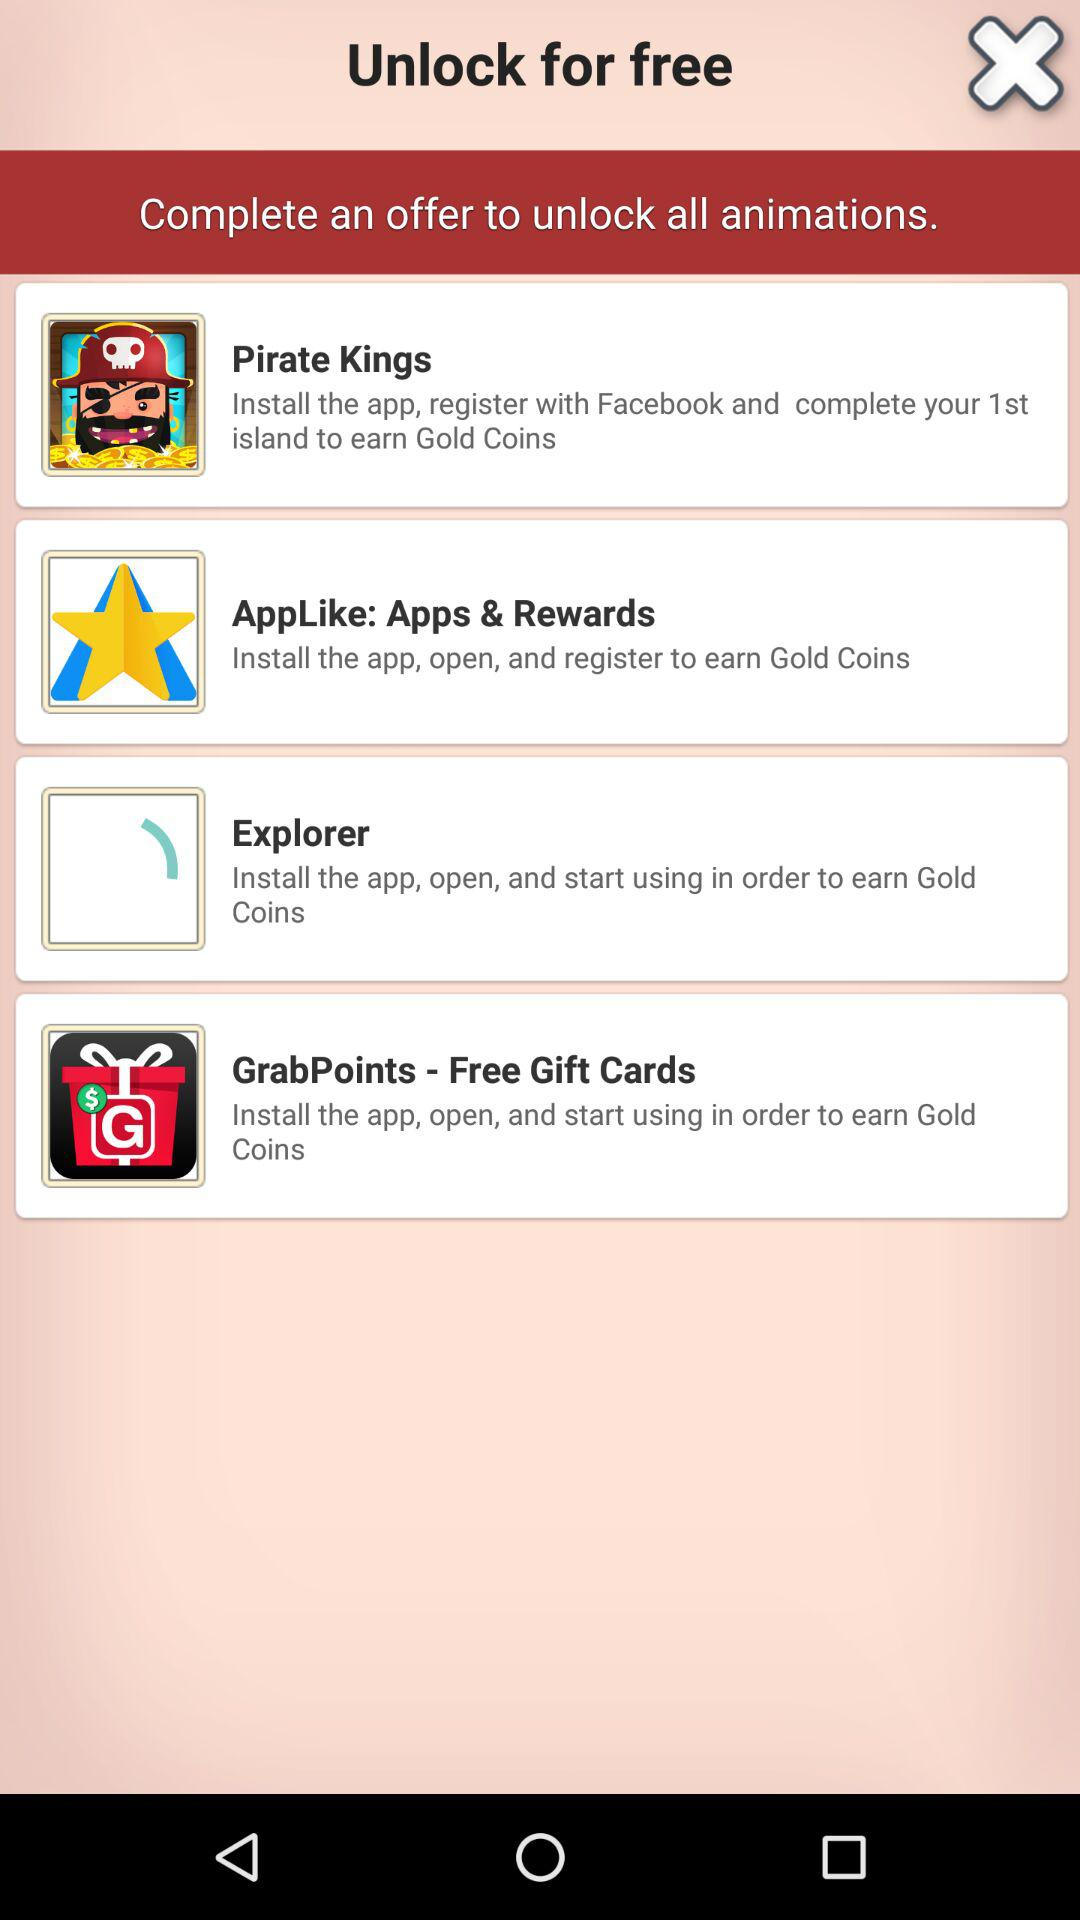How many offers are there to unlock all animations?
Answer the question using a single word or phrase. 4 